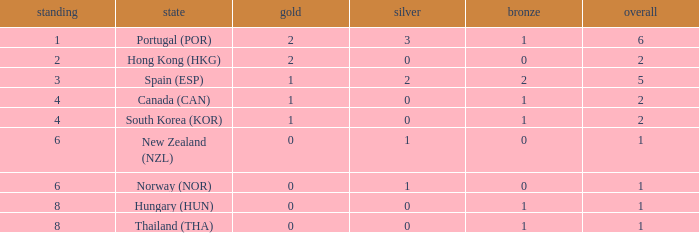Which Rank number has a Silver of 0, Gold of 2 and total smaller than 2? 0.0. 